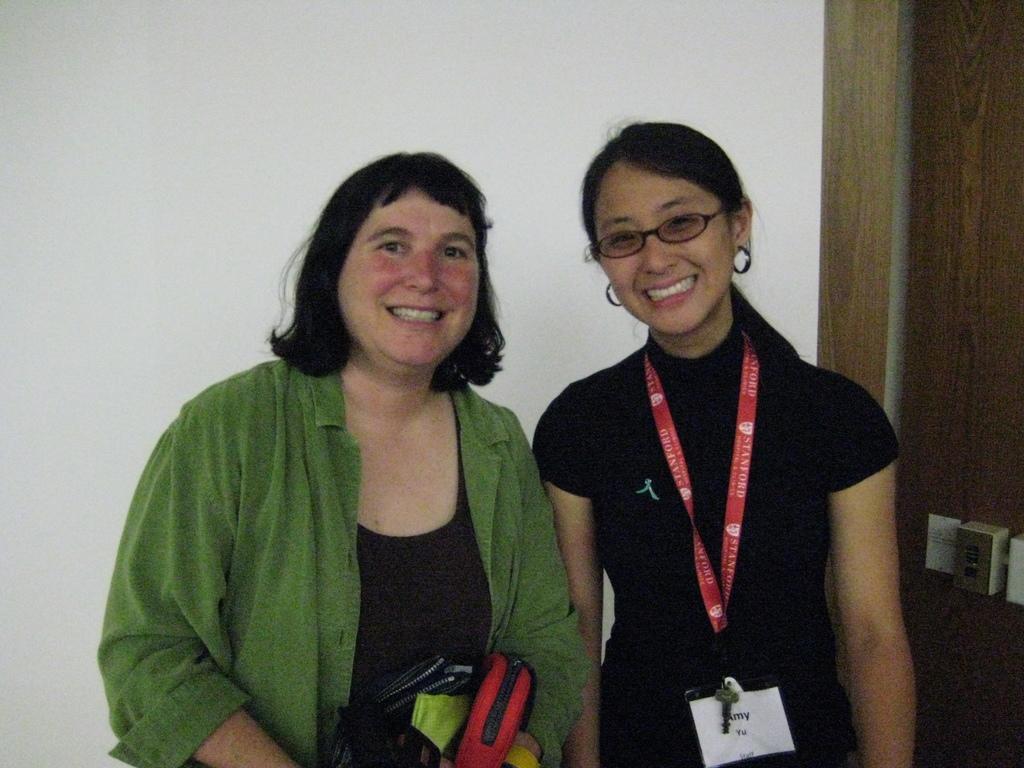Can you describe this image briefly? In the center of the image there are two ladies. In the background of the image there is wall. 